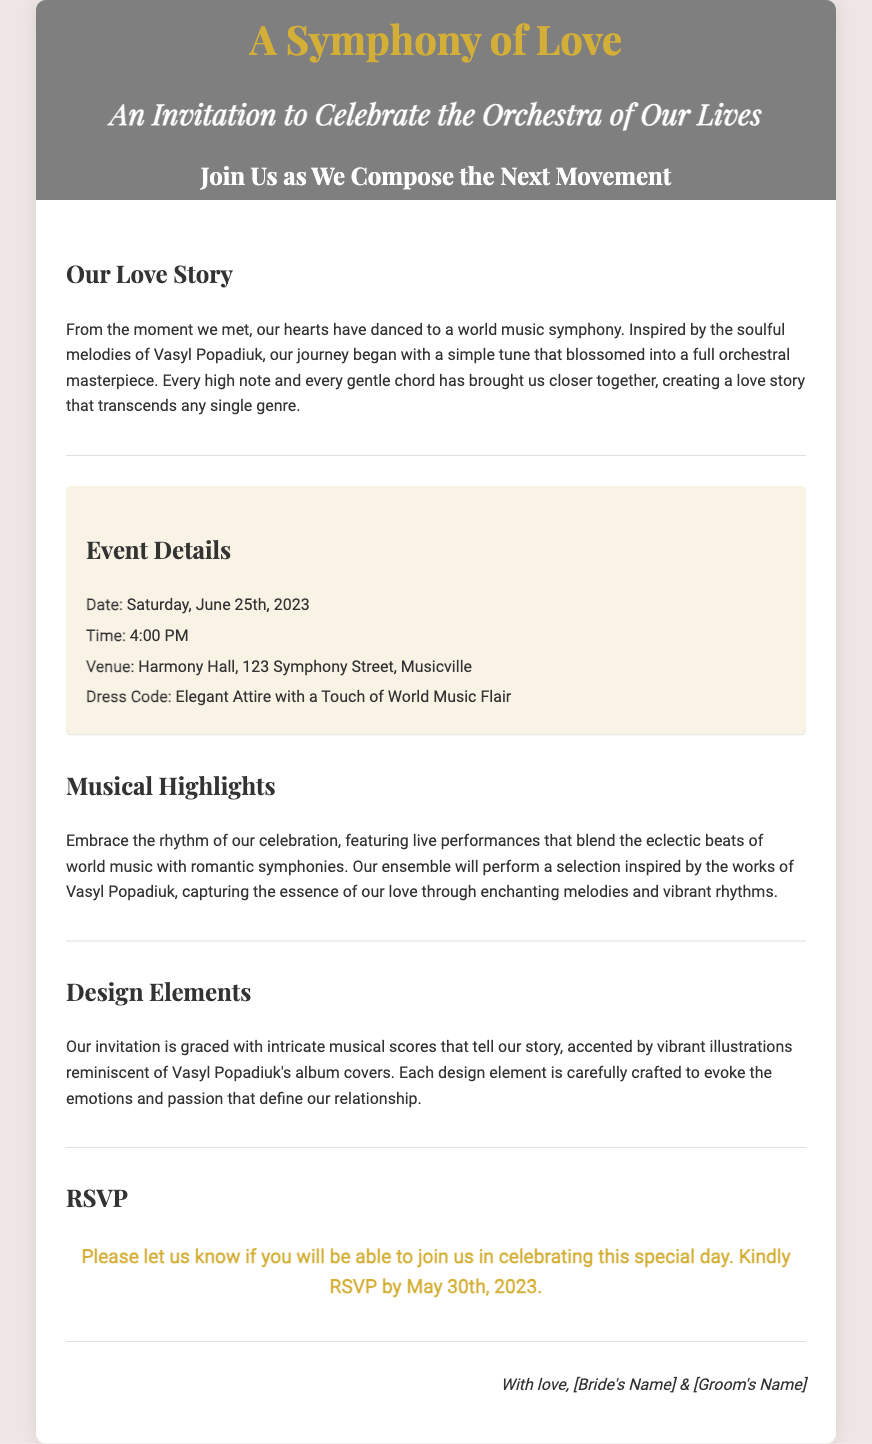What is the title of the wedding invitation? The title of the wedding invitation is prominently displayed at the top of the document.
Answer: A Symphony of Love What is the date of the wedding ceremony? The document explicitly states the date in the event details section.
Answer: Saturday, June 25th, 2023 What is the venue for the celebration? The venue is mentioned in the event details section, providing the location of the event.
Answer: Harmony Hall, 123 Symphony Street, Musicville What is the dress code for the event? The dress code is specified within the event details section, dictating how guests should dress.
Answer: Elegant Attire with a Touch of World Music Flair Who are the couple signing the invitation? The footer of the invitation reveals the names of the couple sending the invitation.
Answer: [Bride's Name] & [Groom's Name] What type of music will be highlighted during the celebration? The document mentions the type of music that will be performed at the event in the musical highlights section.
Answer: World music with romantic symphonies What is the RSVP deadline mentioned in the invitation? The RSVP section outlines when guests should confirm their attendance.
Answer: May 30th, 2023 What kind of design elements are featured in the invitation? The design elements are described with reference to specific artistic influences in the document.
Answer: Musical scores and vibrant illustrations What inspiration is mentioned for their love story? The couple's love story references a specific artist that influenced their journey together.
Answer: Vasyl Popadiuk 